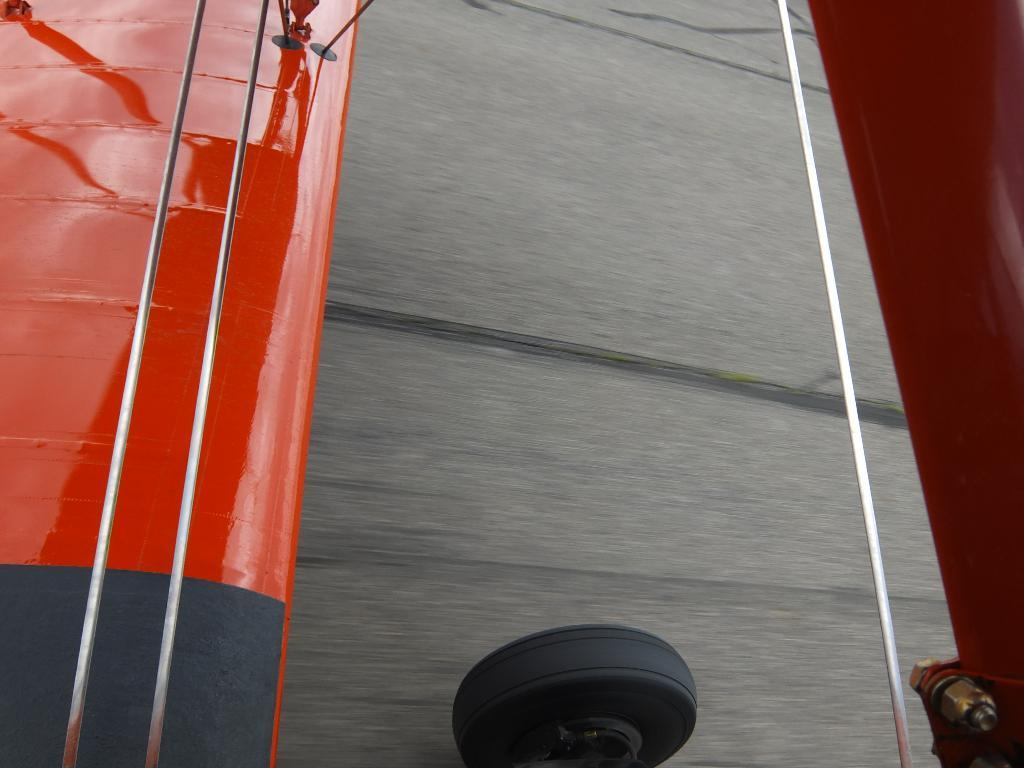What is located at the bottom of the image? There is a tire at the bottom of the image. What can be seen on the sides of the tire? There are rods on the sides of the tire. What do the red-colored objects resemble? The red-colored objects resemble an airplane wing. What type of trouble is the airplane wing experiencing in the image? There is no airplane wing experiencing trouble in the image; the red-colored objects resemble an airplane wing. 